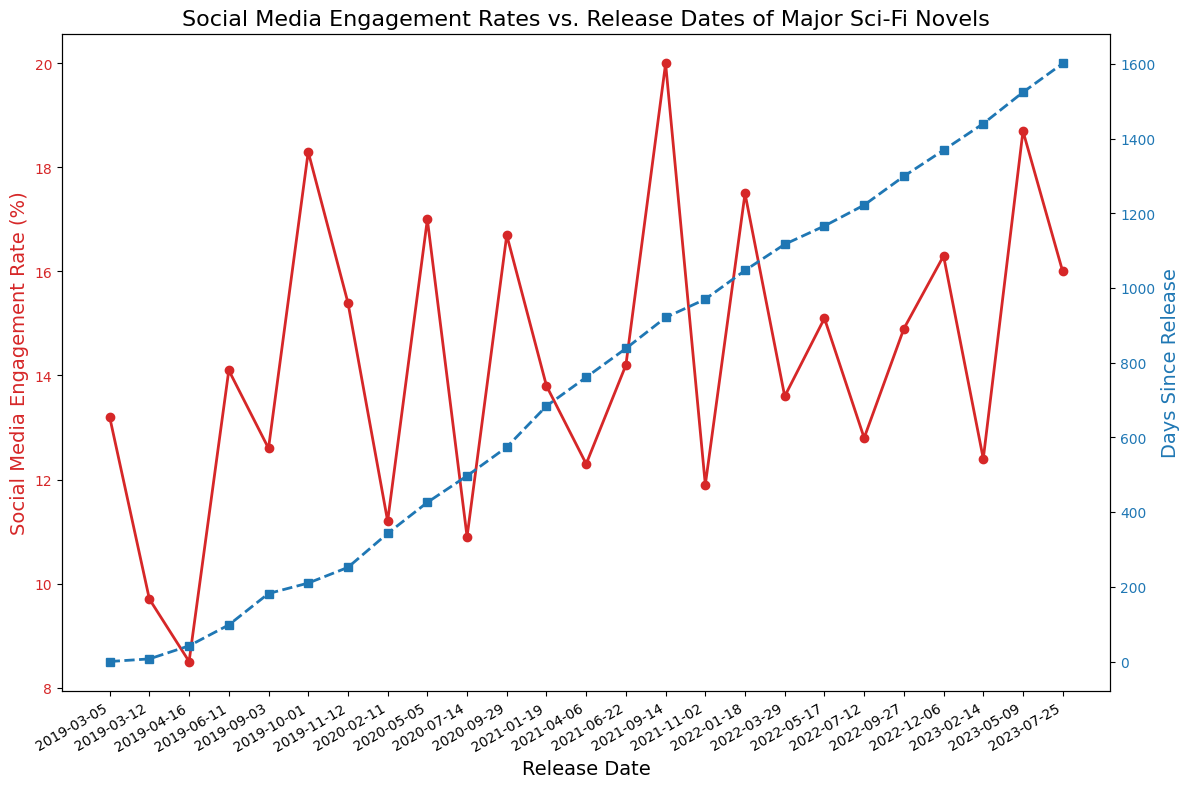What is the highest social media engagement rate and which novel does it correspond to? The red line indicates social media engagement rates, and its highest point corresponds to the novel "Leviathan Falls," which has an engagement rate of 20.0%.
Answer: 20.0%, "Leviathan Falls" Which novel had the lowest social media engagement rate and what was the rate? The lowest point of the red line corresponds to the novel "The Raven Tower," which has an engagement rate of 8.5%.
Answer: 8.5%, "The Raven Tower" How many days since release are there for the latest novel, "Eyes of the Void"? The blue line's last data point corresponds to "Eyes of the Void," which is marked as having 1601 days since release.
Answer: 1601 Compare the social media engagement rates of "This Is How You Lose the Time War" and "The Kaiju Preservation Society." Which one is higher and by how much? Find the points on the red line that correspond to the titles. "This Is How You Lose the Time War" has an engagement rate of 14.1% while "The Kaiju Preservation Society" has 13.6%. The difference is 14.1% - 13.6% = 0.5%.
Answer: "This Is How You Lose the Time War" by 0.5% What is the average social media engagement rate for the novels released in 2020? The novels released in 2020 are "The Unspoken Name," "The Last Emperox," "Axiom's End," and "Piranesi." Their engagement rates are 11.2%, 17.0%, 10.9%, and 16.7%, respectively. The average is calculated as (11.2 + 17.0 + 10.9 + 16.7) / 4 = 13.95%.
Answer: 13.95% How many novels have a social media engagement rate higher than 15%? Visually inspect the red line and count the novels with peaks higher than 15%. The novels are: "The Testaments," "The Starless Sea," "The Last Emperox," "Piranesi," "Leviathan Falls," "Light from Uncommon Stars," "Lone Women," and "Eyes of the Void." There are 8 novels.
Answer: 8 Which novel released in 2021 has the highest social media engagement rate and what is the rate? Find the points for novels in 2021 and compare their engagement rates. "Leviathan Falls" has the highest rate of 20.0%.
Answer: "Leviathan Falls," 20.0% Is there any pattern observable between the number of days since release and the engagement rates? By observing the red and blue lines in the plot, there is no consistent pattern that shows higher or lower engagement rates tied to the number of days since release. Peaks and valleys in engagement rates appear independently of the blue line's trend.
Answer: No consistent pattern 